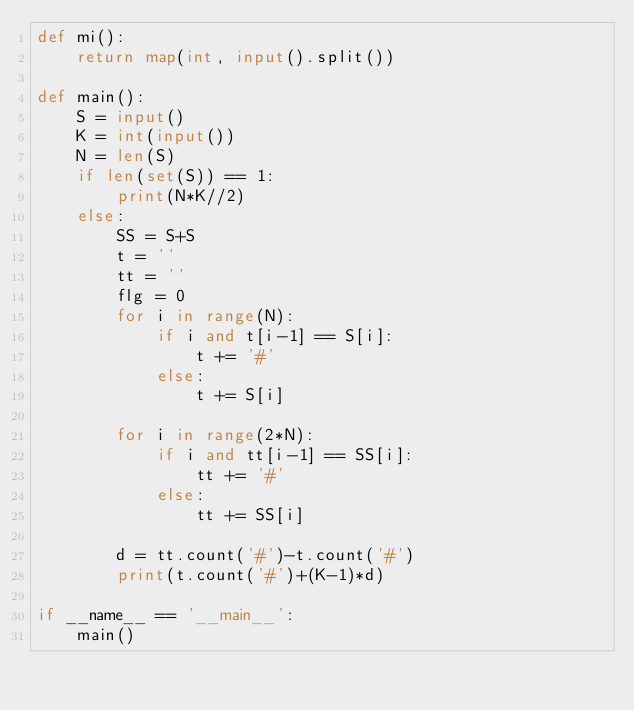Convert code to text. <code><loc_0><loc_0><loc_500><loc_500><_Python_>def mi():
    return map(int, input().split())

def main():
    S = input()
    K = int(input())
    N = len(S)
    if len(set(S)) == 1:
        print(N*K//2)
    else:
        SS = S+S
        t = ''
        tt = ''
        flg = 0
        for i in range(N):
            if i and t[i-1] == S[i]:
                t += '#'
            else:
                t += S[i]

        for i in range(2*N):
            if i and tt[i-1] == SS[i]:
                tt += '#'
            else:
                tt += SS[i]

        d = tt.count('#')-t.count('#')
        print(t.count('#')+(K-1)*d)

if __name__ == '__main__':
    main()
</code> 